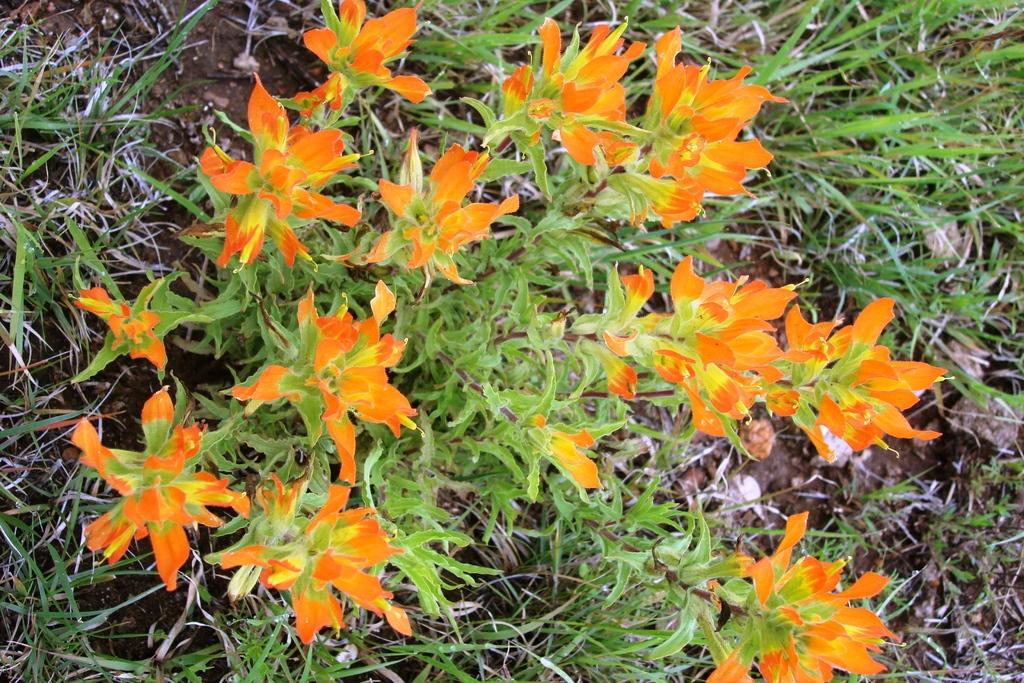What type of plant is present in the image? There is a plant with flowers in the image. What color are the flowers on the plant? The flowers are orange in color. What can be seen in the background of the image? There is grass visible in the background of the image. What scent can be detected from the flowers in the image? The image does not provide any information about the scent of the flowers, so it cannot be determined from the image. 